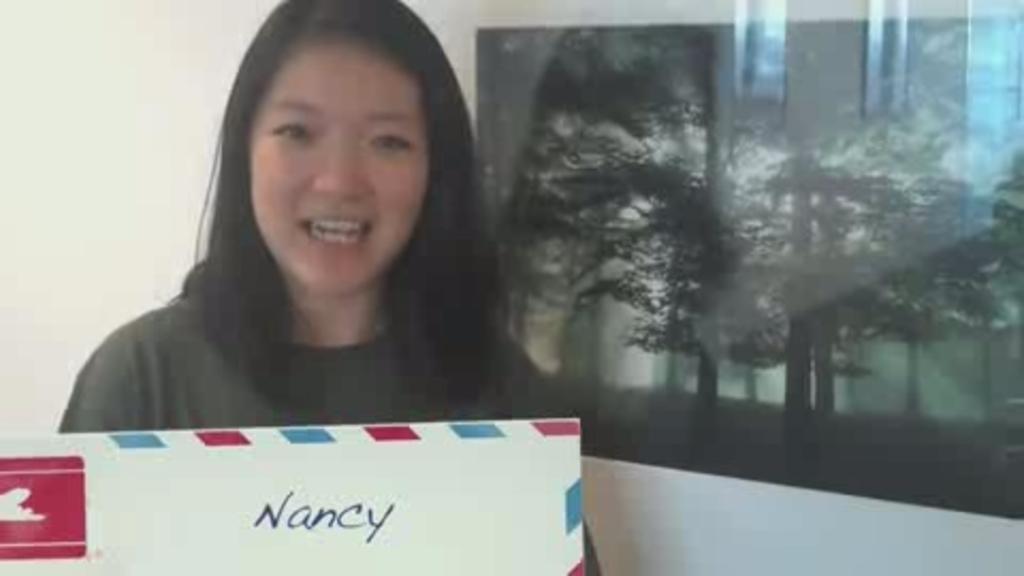Describe this image in one or two sentences. In this picture we can see a woman holding a board, beside we can see one more board to the wall. 